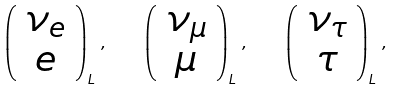Convert formula to latex. <formula><loc_0><loc_0><loc_500><loc_500>\left ( \begin{array} { c } \nu _ { e } \\ e \end{array} \right ) _ { L } \, , \quad \left ( \begin{array} { c } \nu _ { \mu } \\ \mu \end{array} \right ) _ { L } \, , \quad \left ( \begin{array} { c } \nu _ { \tau } \\ \tau \end{array} \right ) _ { L } \, ,</formula> 